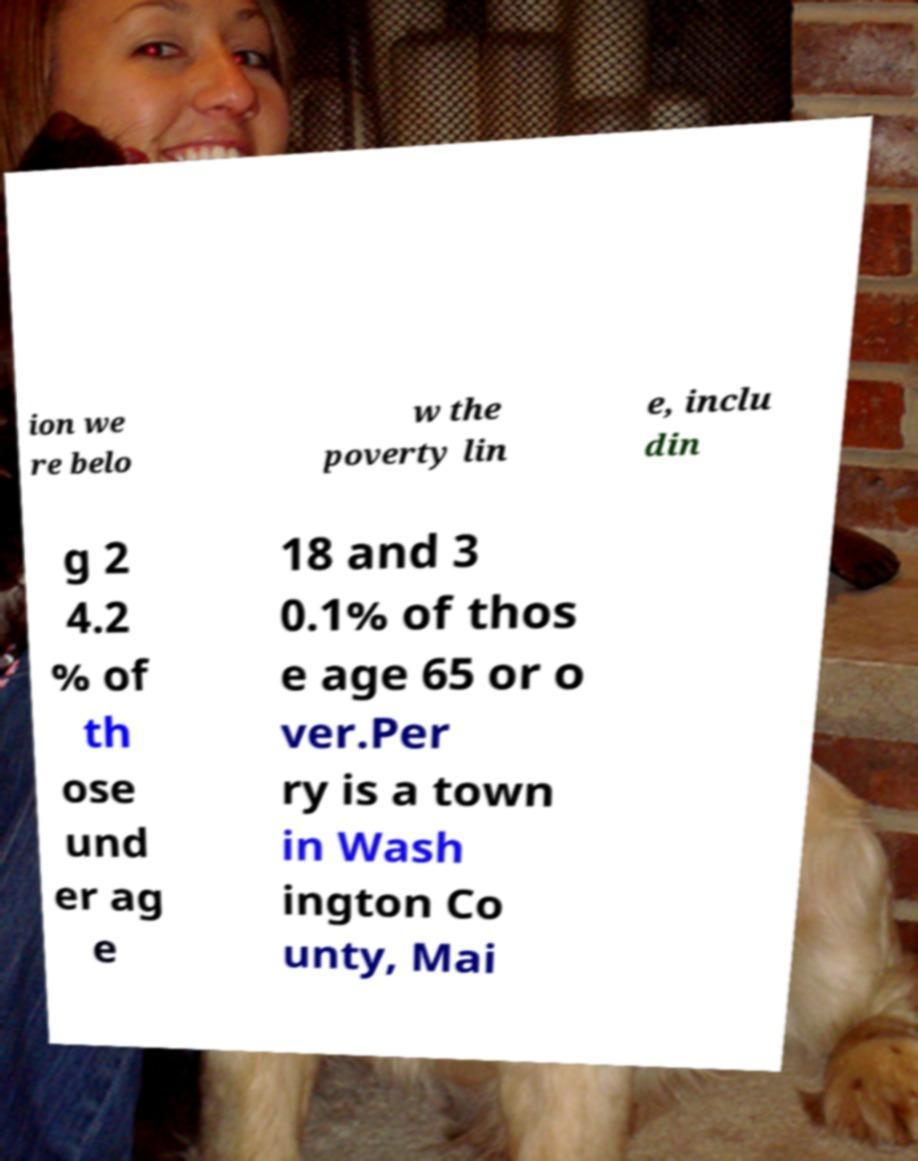Can you accurately transcribe the text from the provided image for me? ion we re belo w the poverty lin e, inclu din g 2 4.2 % of th ose und er ag e 18 and 3 0.1% of thos e age 65 or o ver.Per ry is a town in Wash ington Co unty, Mai 